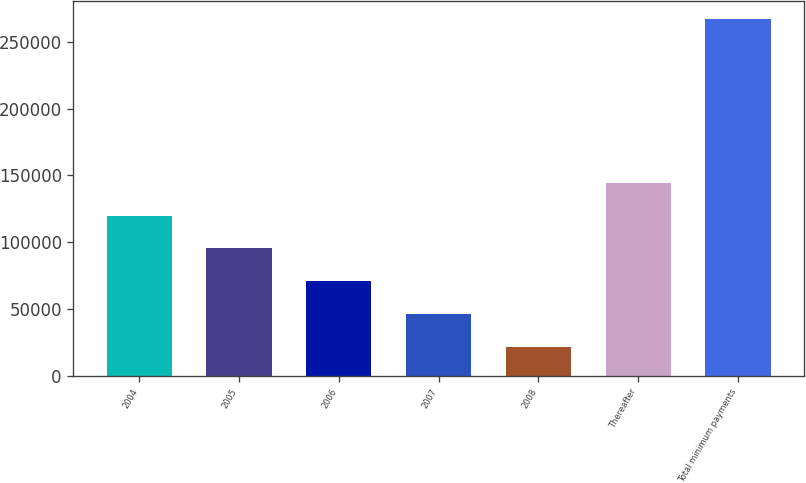Convert chart to OTSL. <chart><loc_0><loc_0><loc_500><loc_500><bar_chart><fcel>2004<fcel>2005<fcel>2006<fcel>2007<fcel>2008<fcel>Thereafter<fcel>Total minimum payments<nl><fcel>119770<fcel>95260.5<fcel>70751<fcel>46241.5<fcel>21732<fcel>144280<fcel>266827<nl></chart> 